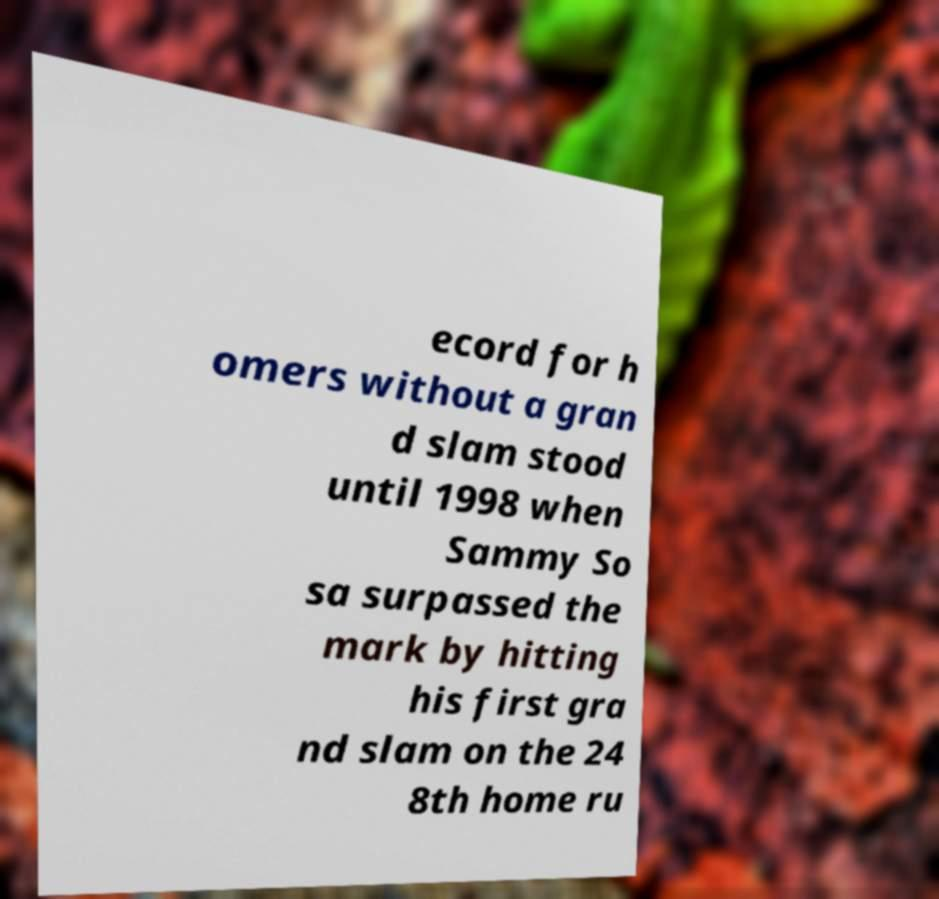Can you read and provide the text displayed in the image?This photo seems to have some interesting text. Can you extract and type it out for me? ecord for h omers without a gran d slam stood until 1998 when Sammy So sa surpassed the mark by hitting his first gra nd slam on the 24 8th home ru 